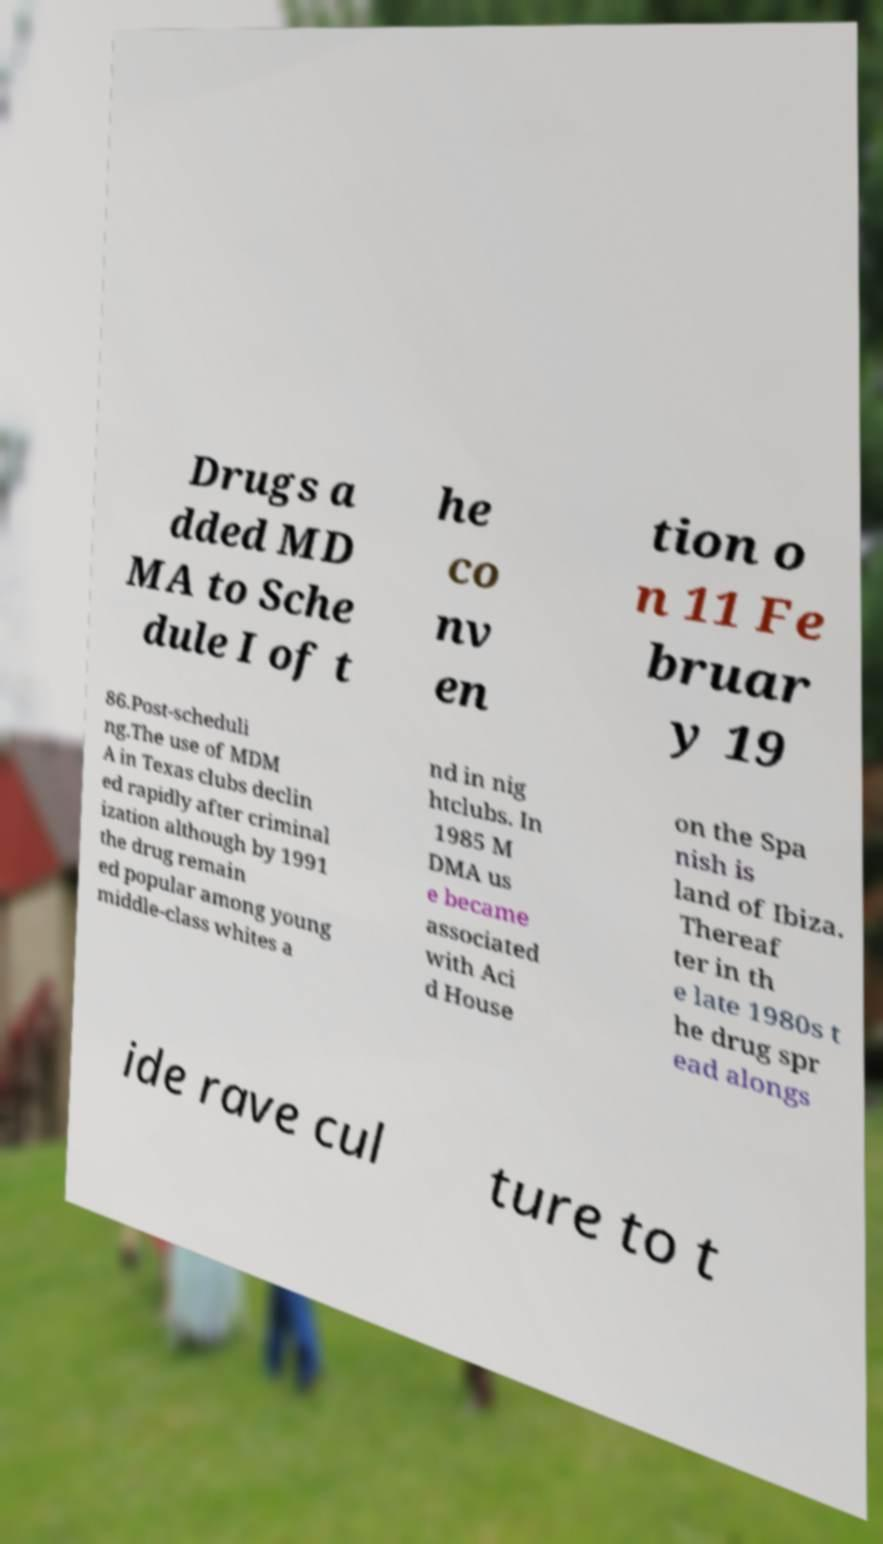I need the written content from this picture converted into text. Can you do that? Drugs a dded MD MA to Sche dule I of t he co nv en tion o n 11 Fe bruar y 19 86.Post-scheduli ng.The use of MDM A in Texas clubs declin ed rapidly after criminal ization although by 1991 the drug remain ed popular among young middle-class whites a nd in nig htclubs. In 1985 M DMA us e became associated with Aci d House on the Spa nish is land of Ibiza. Thereaf ter in th e late 1980s t he drug spr ead alongs ide rave cul ture to t 